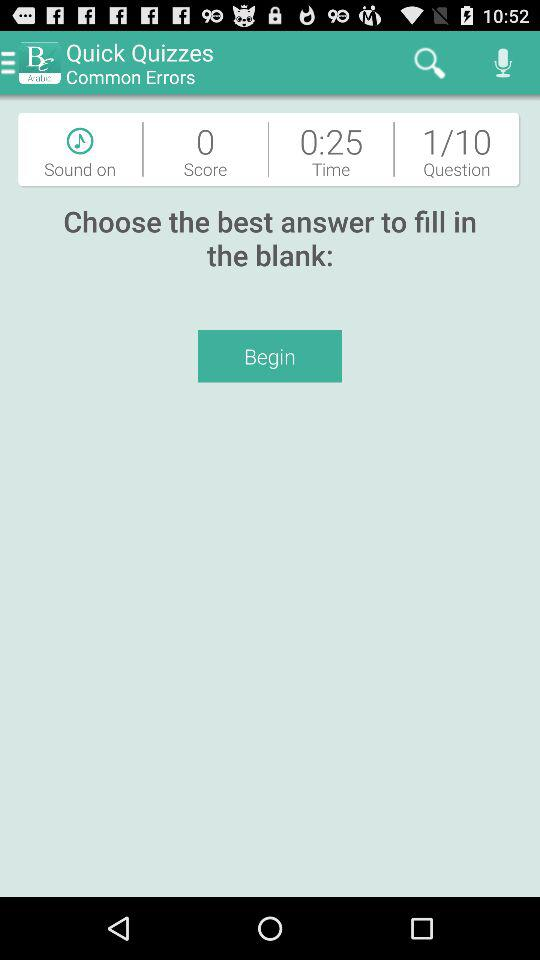What is the status of "Sound"? The status is "on". 